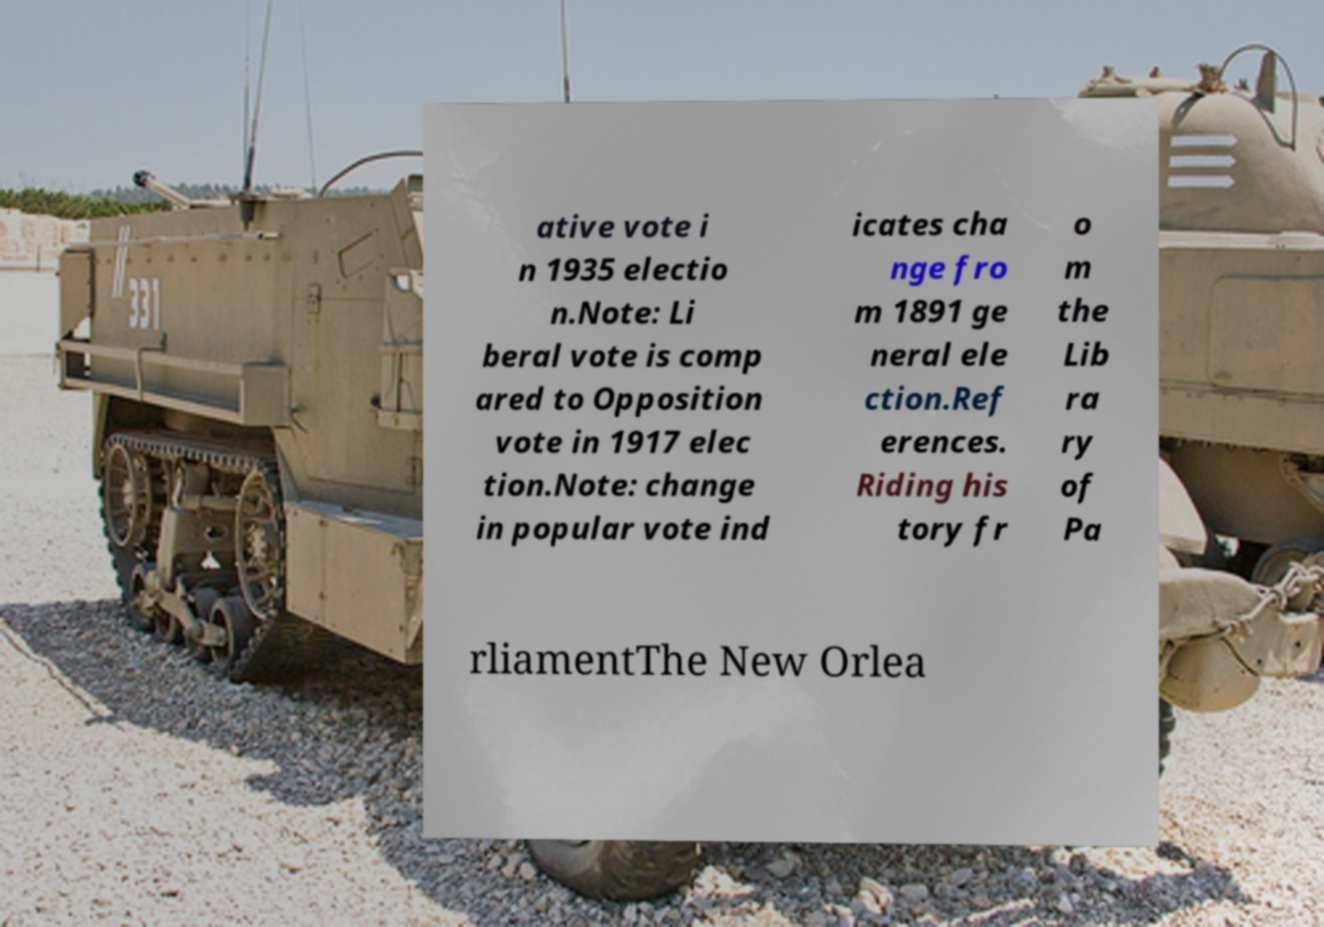Please identify and transcribe the text found in this image. ative vote i n 1935 electio n.Note: Li beral vote is comp ared to Opposition vote in 1917 elec tion.Note: change in popular vote ind icates cha nge fro m 1891 ge neral ele ction.Ref erences. Riding his tory fr o m the Lib ra ry of Pa rliamentThe New Orlea 